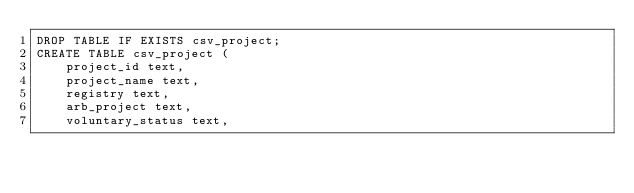<code> <loc_0><loc_0><loc_500><loc_500><_SQL_>DROP TABLE IF EXISTS csv_project;
CREATE TABLE csv_project (
    project_id text,
    project_name text,
    registry text,
    arb_project text,
    voluntary_status text,</code> 